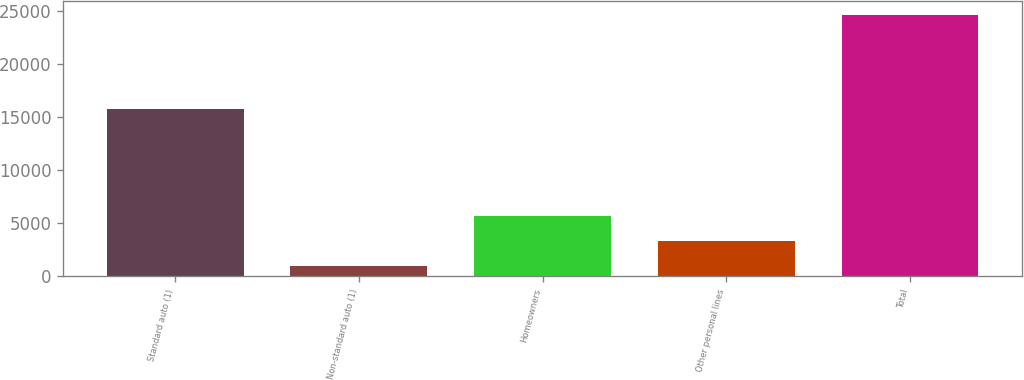Convert chart. <chart><loc_0><loc_0><loc_500><loc_500><bar_chart><fcel>Standard auto (1)<fcel>Non-standard auto (1)<fcel>Homeowners<fcel>Other personal lines<fcel>Total<nl><fcel>15763<fcel>927<fcel>5670<fcel>3298.5<fcel>24642<nl></chart> 